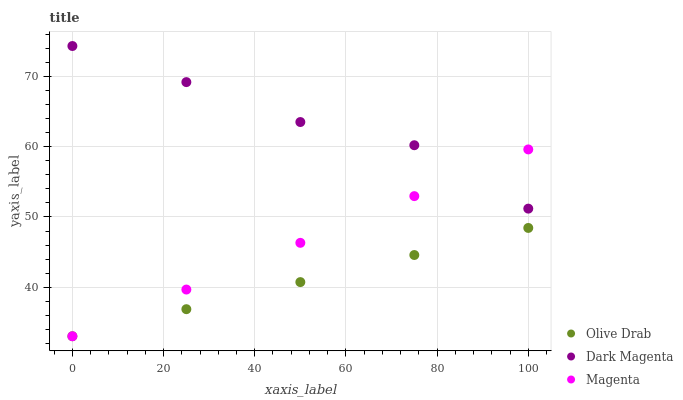Does Olive Drab have the minimum area under the curve?
Answer yes or no. Yes. Does Dark Magenta have the maximum area under the curve?
Answer yes or no. Yes. Does Dark Magenta have the minimum area under the curve?
Answer yes or no. No. Does Olive Drab have the maximum area under the curve?
Answer yes or no. No. Is Magenta the smoothest?
Answer yes or no. Yes. Is Dark Magenta the roughest?
Answer yes or no. Yes. Is Dark Magenta the smoothest?
Answer yes or no. No. Is Olive Drab the roughest?
Answer yes or no. No. Does Magenta have the lowest value?
Answer yes or no. Yes. Does Dark Magenta have the lowest value?
Answer yes or no. No. Does Dark Magenta have the highest value?
Answer yes or no. Yes. Does Olive Drab have the highest value?
Answer yes or no. No. Is Olive Drab less than Dark Magenta?
Answer yes or no. Yes. Is Dark Magenta greater than Olive Drab?
Answer yes or no. Yes. Does Olive Drab intersect Magenta?
Answer yes or no. Yes. Is Olive Drab less than Magenta?
Answer yes or no. No. Is Olive Drab greater than Magenta?
Answer yes or no. No. Does Olive Drab intersect Dark Magenta?
Answer yes or no. No. 